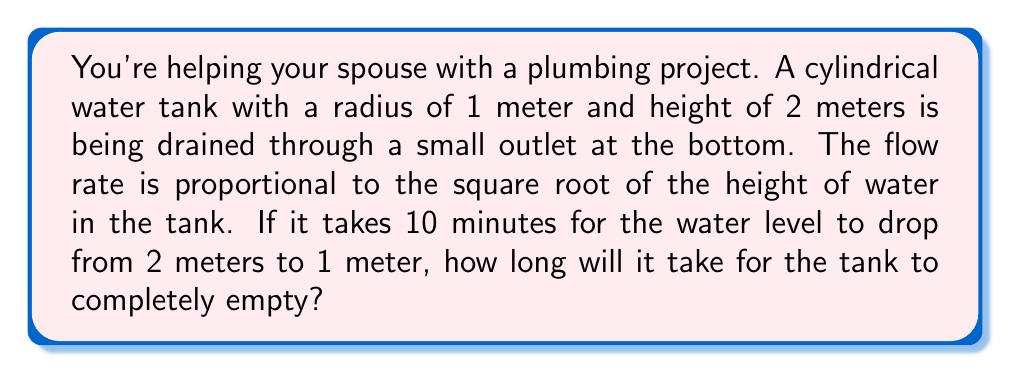Can you solve this math problem? Let's approach this step-by-step using a differential equation:

1) Let $h(t)$ be the height of water in the tank at time $t$.

2) The volume $V$ of water in the tank is given by $V = \pi r^2 h$, where $r$ is the radius.

3) The rate of change of volume is proportional to the square root of height:

   $$\frac{dV}{dt} = -k\sqrt{h}$$

   (negative because the volume is decreasing)

4) Substituting $V = \pi r^2 h$ and differentiating:

   $$\pi r^2 \frac{dh}{dt} = -k\sqrt{h}$$

5) Rearranging:

   $$\frac{dh}{dt} = -\frac{k}{\pi r^2}\sqrt{h} = -C\sqrt{h}$$

   where $C = \frac{k}{\pi r^2}$

6) Separating variables and integrating:

   $$\int_{h_0}^{h} \frac{dh}{\sqrt{h}} = -C\int_{0}^{t} dt$$

7) Solving:

   $$2\sqrt{h} - 2\sqrt{h_0} = -Ct$$

8) Given that it takes 10 minutes for $h$ to change from 2 to 1:

   $$2(\sqrt{1} - \sqrt{2}) = -C(10)$$

9) Solving for $C$:

   $$C = \frac{2(\sqrt{2} - 1)}{10} \approx 0.0828$$

10) Now, for the tank to empty completely, $h$ goes from 2 to 0:

    $$2(0 - \sqrt{2}) = -0.0828t$$

11) Solving for $t$:

    $$t = \frac{2\sqrt{2}}{0.0828} \approx 34.14$$

Therefore, it will take approximately 34.14 minutes for the tank to empty completely.
Answer: 34.14 minutes 